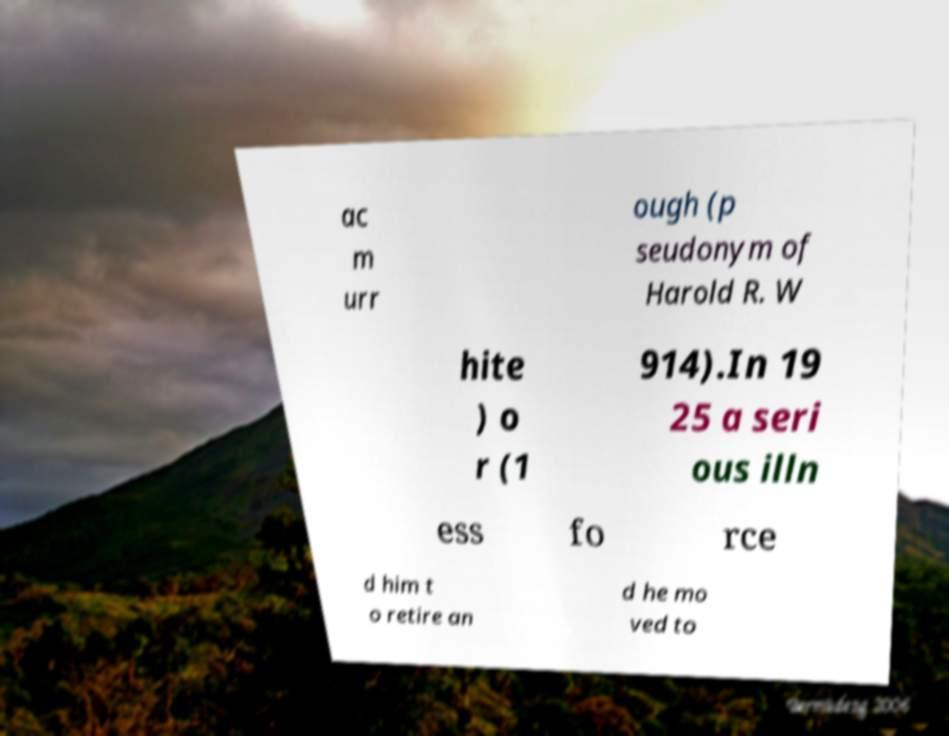Please identify and transcribe the text found in this image. ac m urr ough (p seudonym of Harold R. W hite ) o r (1 914).In 19 25 a seri ous illn ess fo rce d him t o retire an d he mo ved to 